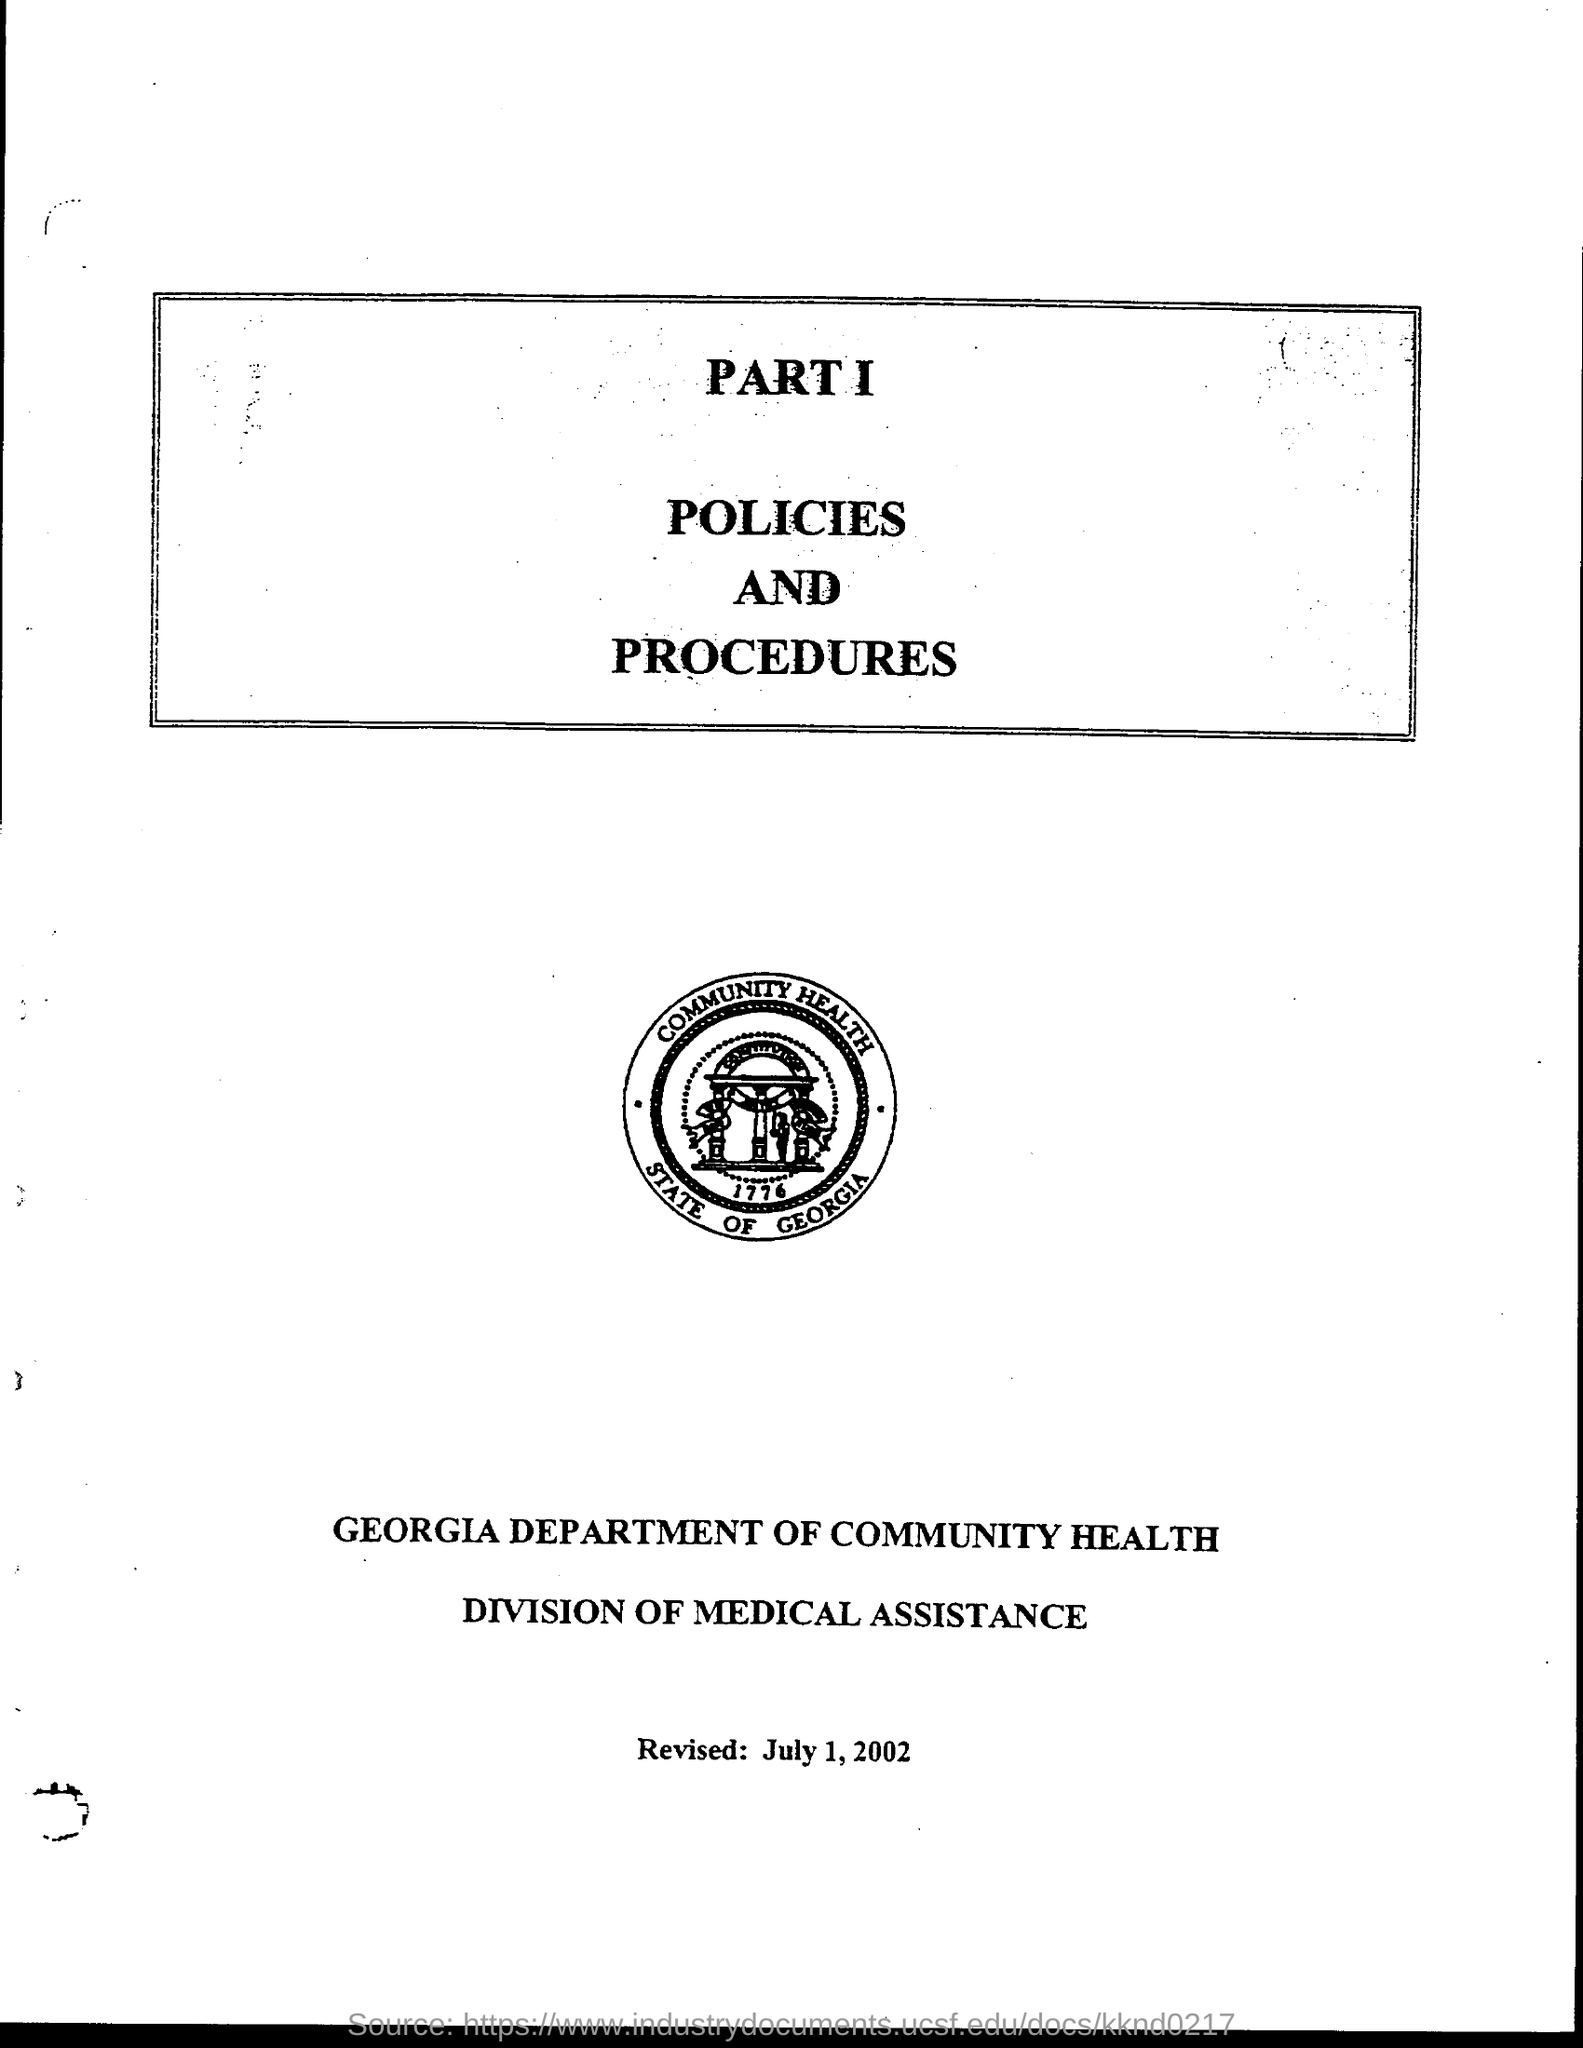What is the revised date?
Your response must be concise. July 1, 2002. Which year is written on the seal in round shape?
Give a very brief answer. 1776. What is the department?
Your answer should be very brief. Georgia Department of Community Health. 